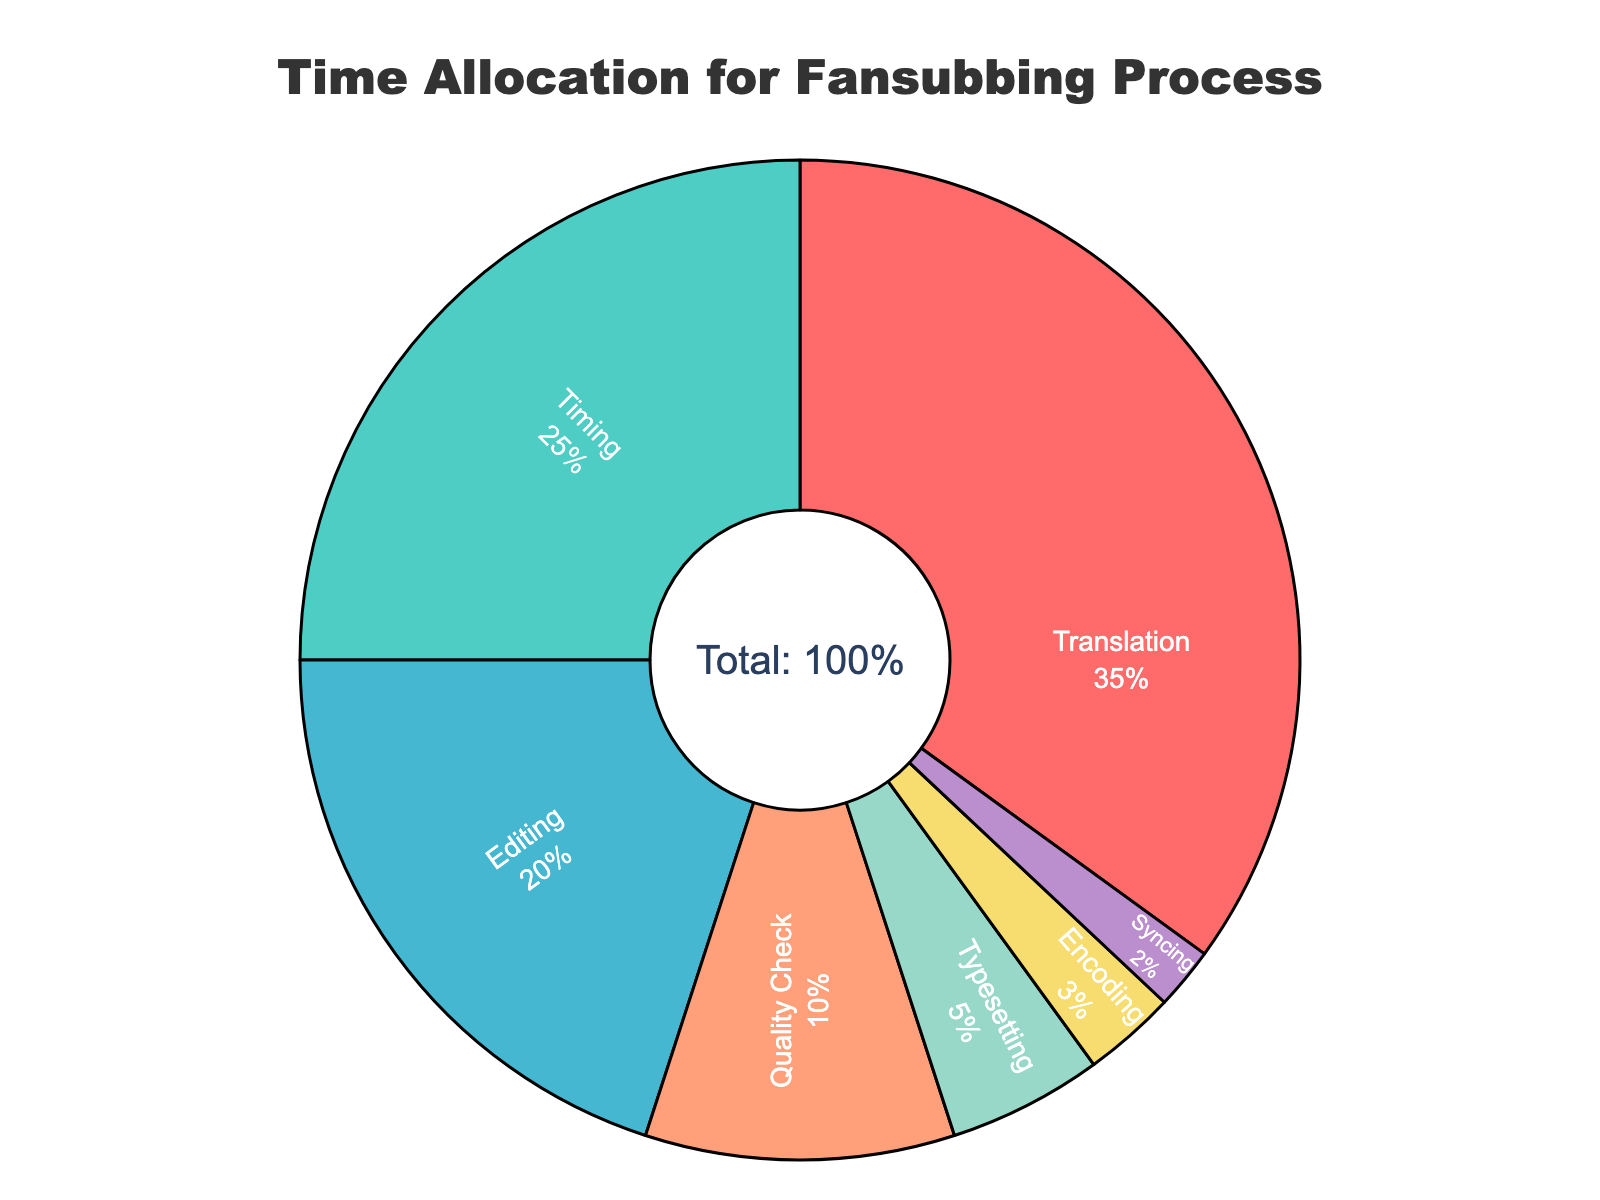Which stage takes up the largest percentage of time in the fansubbing process? By looking at the pie chart, we identify the segment with the largest proportion. The "Translation" segment is the largest.
Answer: Translation What is the combined time percentage for Editing and Timing? We sum the time percentages of the "Editing" and "Timing" stages. Editing is 20%, and Timing is 25%. So, 20% + 25% = 45%.
Answer: 45% How much more time is allocated to Translation compared to Encoding? We find the time percentages for Translation and Encoding and then subtract the smaller from the larger. Translation is 35%, and Encoding is 3%. So, 35% - 3% = 32%.
Answer: 32% Which stage has the smallest time allocation? By examining the segments, we find the one with the smallest proportion. The "Syncing" segment is the smallest.
Answer: Syncing What is the total time percentage allocated to the stages other than Translation? We sum the time percentages of all stages except Translation. Timing (25%) + Editing (20%) + Quality Check (10%) + Typesetting (5%) + Encoding (3%) + Syncing (2%) = 65%.
Answer: 65% Which stage takes up more time, Quality Check or Typesetting? By comparing the time percentages for Quality Check and Typesetting, we see that Quality Check has 10% and Typesetting has 5%. Quality Check has a larger percentage.
Answer: Quality Check What is the total time percentage for the stages involved after the translation process (Editing, Quality Check, Typesetting, Encoding, Syncing)? We sum the time percentages of stages after Translation: Editing (20%) + Quality Check (10%) + Typesetting (5%) + Encoding (3%) + Syncing (2%) = 40%.
Answer: 40% If the time allocated to Timing were doubled, what would be the new time percentage for Timing? The original time for Timing is 25%. Doubling it would make it 25% × 2 = 50%.
Answer: 50% What percentage of the total time is allocated to stages related to Quality Control (Quality Check, Editing)? We sum the time percentages of Quality Check and Editing. Quality Check is 10%, and Editing is 20%. So, 10% + 20% = 30%.
Answer: 30% What is the difference in time percentage between the Editing and Syncing stages? By finding the time percentages for Editing and Syncing and then subtracting the smaller from the larger, Editing is 20% and Syncing is 2%. So, 20% - 2% = 18%.
Answer: 18% 